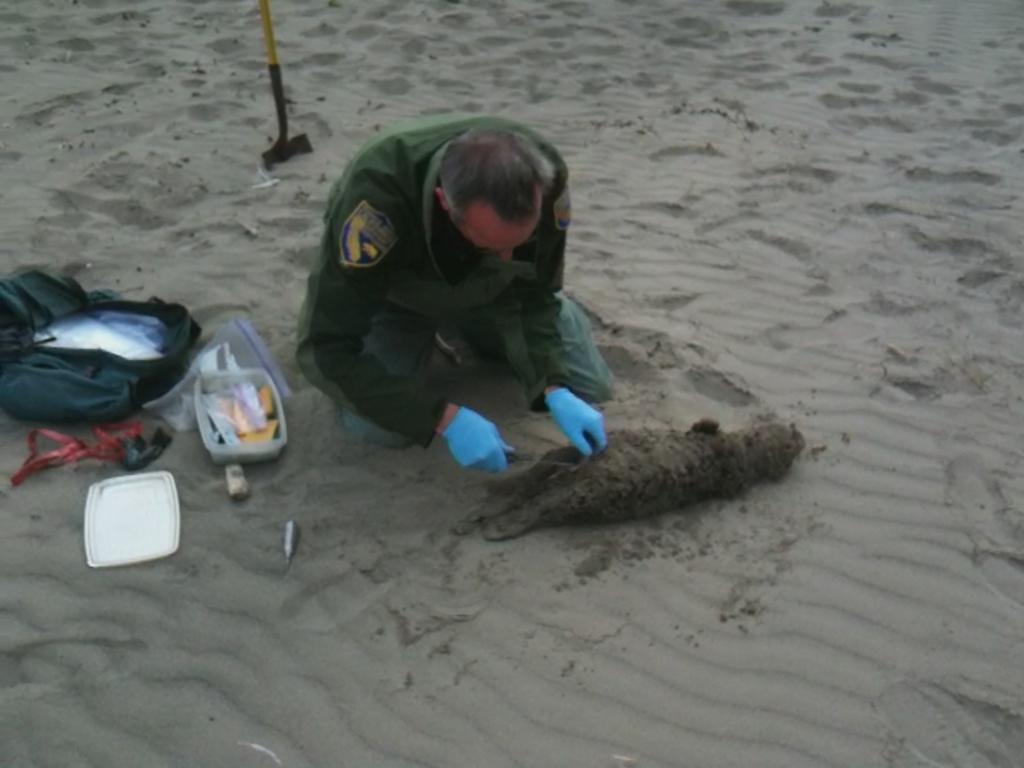Describe this image in one or two sentences. In this image, we can see a person holding an object. We can see the ground covered with sand and some objects like a bag and a box. 